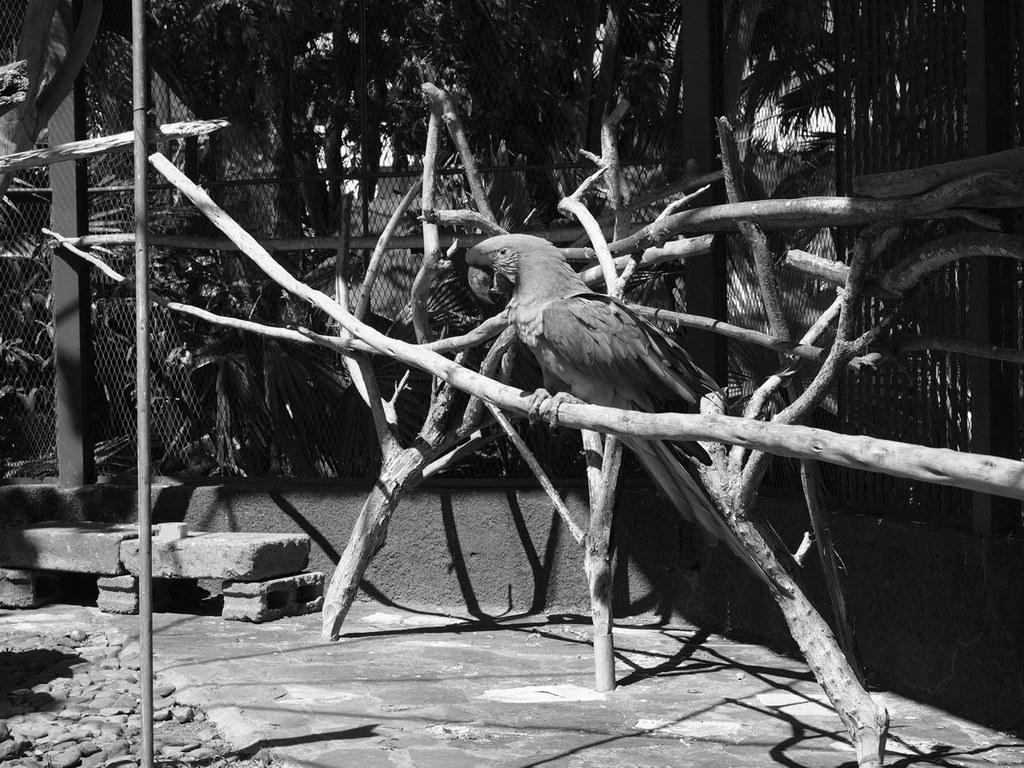What is the color scheme of the image? The image is black and white. What can be seen sitting on wood in the image? There is a bird sitting on wood in the image. What type of objects are on the left side of the image? There are stones on the left side of the image. What is visible in the background of the image? There are trees in the background of the image. Can you see any fairies flying around the bird in the image? There are no fairies present in the image. Is the image depicting a winter scene with snow and ice? The image does not show any snow or ice, and there is no indication of a winter scene. 